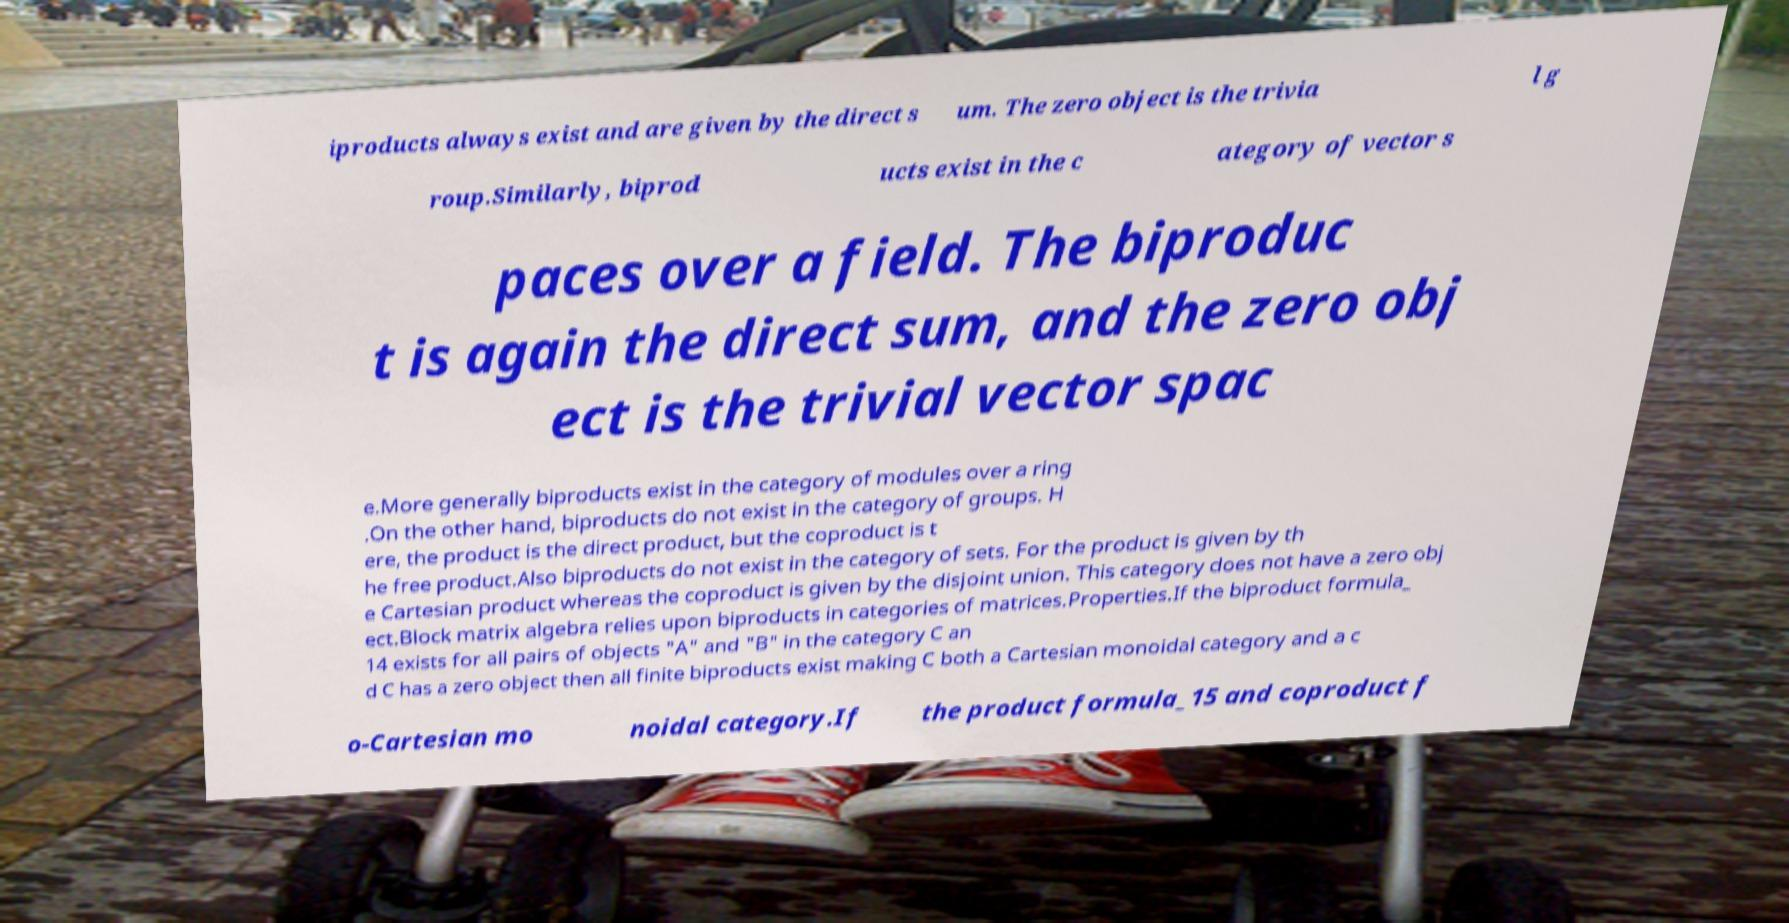For documentation purposes, I need the text within this image transcribed. Could you provide that? iproducts always exist and are given by the direct s um. The zero object is the trivia l g roup.Similarly, biprod ucts exist in the c ategory of vector s paces over a field. The biproduc t is again the direct sum, and the zero obj ect is the trivial vector spac e.More generally biproducts exist in the category of modules over a ring .On the other hand, biproducts do not exist in the category of groups. H ere, the product is the direct product, but the coproduct is t he free product.Also biproducts do not exist in the category of sets. For the product is given by th e Cartesian product whereas the coproduct is given by the disjoint union. This category does not have a zero obj ect.Block matrix algebra relies upon biproducts in categories of matrices.Properties.If the biproduct formula_ 14 exists for all pairs of objects "A" and "B" in the category C an d C has a zero object then all finite biproducts exist making C both a Cartesian monoidal category and a c o-Cartesian mo noidal category.If the product formula_15 and coproduct f 